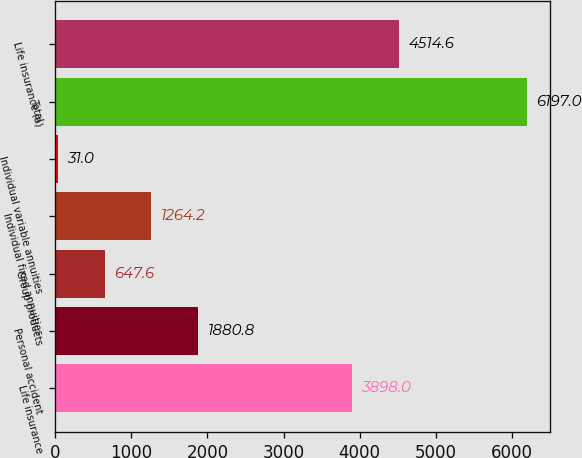Convert chart. <chart><loc_0><loc_0><loc_500><loc_500><bar_chart><fcel>Life insurance<fcel>Personal accident<fcel>Group products<fcel>Individual fixed annuities<fcel>Individual variable annuities<fcel>Total<fcel>Life insurance (a)<nl><fcel>3898<fcel>1880.8<fcel>647.6<fcel>1264.2<fcel>31<fcel>6197<fcel>4514.6<nl></chart> 